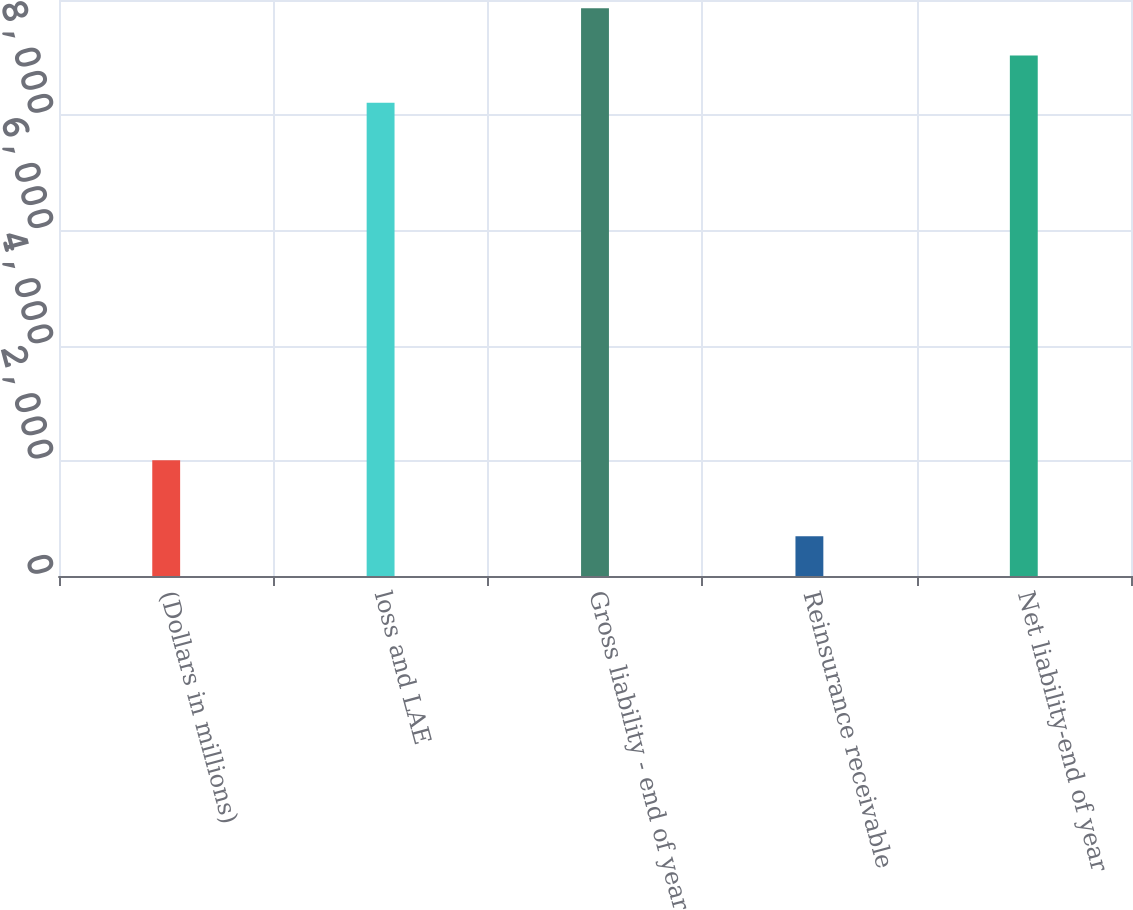Convert chart to OTSL. <chart><loc_0><loc_0><loc_500><loc_500><bar_chart><fcel>(Dollars in millions)<fcel>loss and LAE<fcel>Gross liability - end of year<fcel>Reinsurance receivable<fcel>Net liability-end of year<nl><fcel>2008<fcel>8214.7<fcel>9857.64<fcel>691.2<fcel>9036.17<nl></chart> 